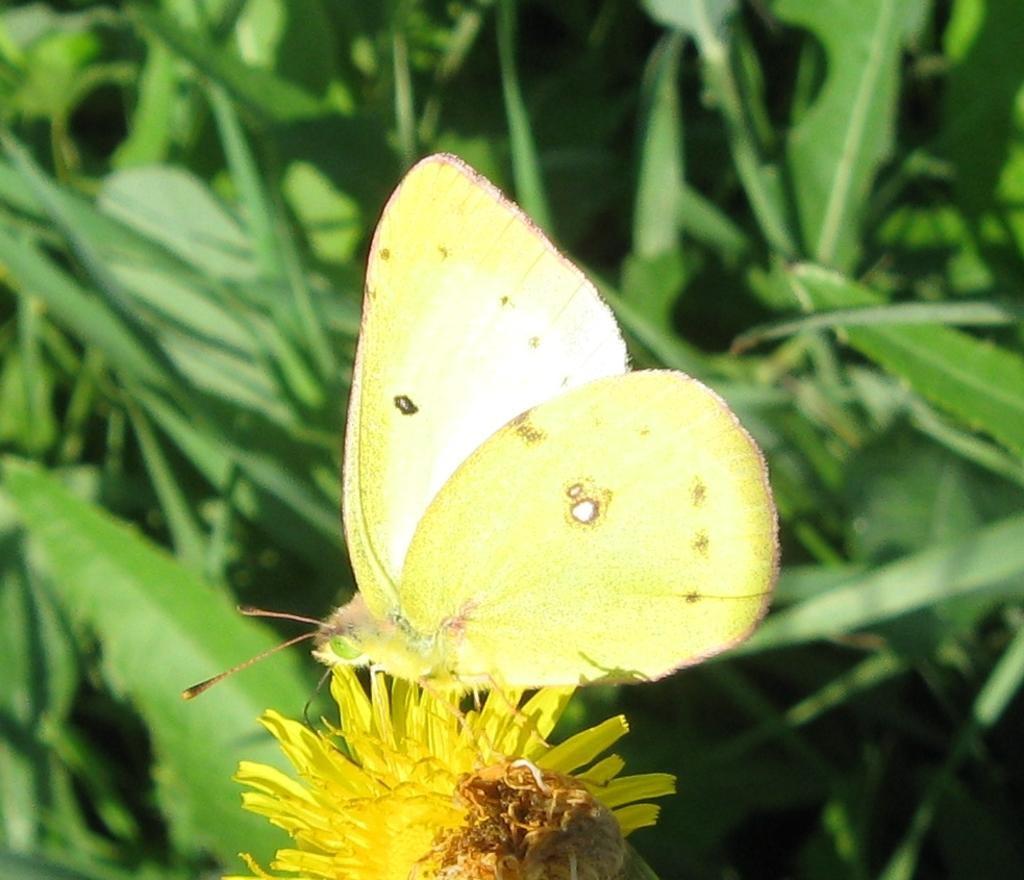What is the main subject of the image? There is a butterfly in the image. Where is the butterfly located? The butterfly is on a flower. What can be seen in the background of the image? There are plants in the background of the image. What type of feast is the butterfly attending in the image? There is no feast present in the image, and the butterfly is not attending any event. 